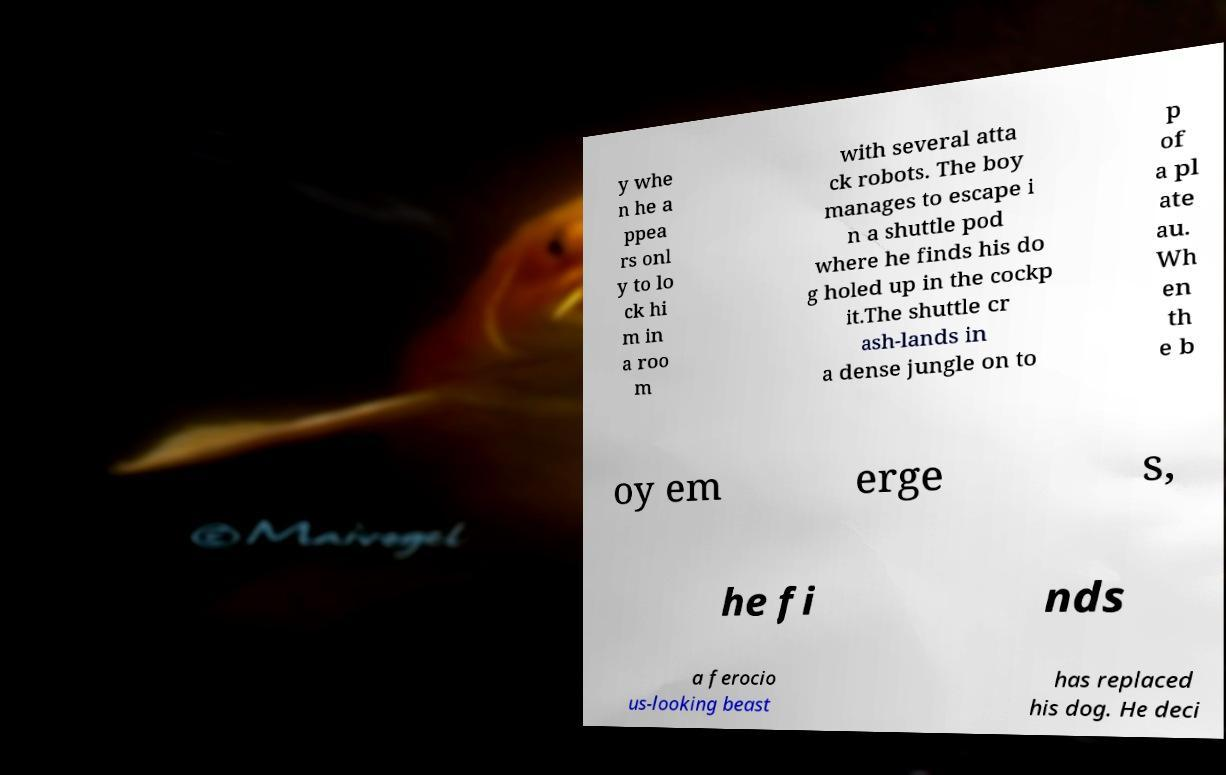Please read and relay the text visible in this image. What does it say? y whe n he a ppea rs onl y to lo ck hi m in a roo m with several atta ck robots. The boy manages to escape i n a shuttle pod where he finds his do g holed up in the cockp it.The shuttle cr ash-lands in a dense jungle on to p of a pl ate au. Wh en th e b oy em erge s, he fi nds a ferocio us-looking beast has replaced his dog. He deci 